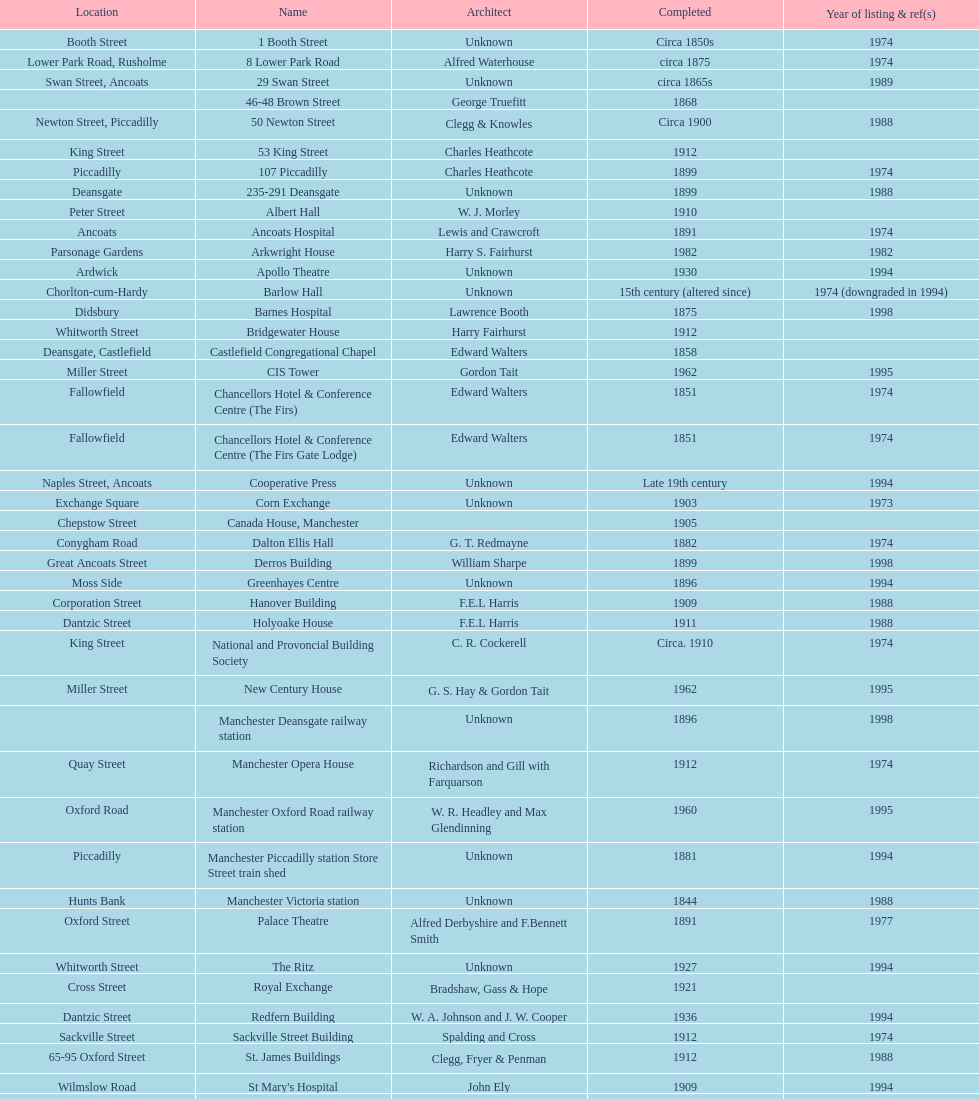How many names are listed with an image? 39. Would you be able to parse every entry in this table? {'header': ['Location', 'Name', 'Architect', 'Completed', 'Year of listing & ref(s)'], 'rows': [['Booth Street', '1 Booth Street', 'Unknown', 'Circa 1850s', '1974'], ['Lower Park Road, Rusholme', '8 Lower Park Road', 'Alfred Waterhouse', 'circa 1875', '1974'], ['Swan Street, Ancoats', '29 Swan Street', 'Unknown', 'circa 1865s', '1989'], ['', '46-48 Brown Street', 'George Truefitt', '1868', ''], ['Newton Street, Piccadilly', '50 Newton Street', 'Clegg & Knowles', 'Circa 1900', '1988'], ['King Street', '53 King Street', 'Charles Heathcote', '1912', ''], ['Piccadilly', '107 Piccadilly', 'Charles Heathcote', '1899', '1974'], ['Deansgate', '235-291 Deansgate', 'Unknown', '1899', '1988'], ['Peter Street', 'Albert Hall', 'W. J. Morley', '1910', ''], ['Ancoats', 'Ancoats Hospital', 'Lewis and Crawcroft', '1891', '1974'], ['Parsonage Gardens', 'Arkwright House', 'Harry S. Fairhurst', '1982', '1982'], ['Ardwick', 'Apollo Theatre', 'Unknown', '1930', '1994'], ['Chorlton-cum-Hardy', 'Barlow Hall', 'Unknown', '15th century (altered since)', '1974 (downgraded in 1994)'], ['Didsbury', 'Barnes Hospital', 'Lawrence Booth', '1875', '1998'], ['Whitworth Street', 'Bridgewater House', 'Harry Fairhurst', '1912', ''], ['Deansgate, Castlefield', 'Castlefield Congregational Chapel', 'Edward Walters', '1858', ''], ['Miller Street', 'CIS Tower', 'Gordon Tait', '1962', '1995'], ['Fallowfield', 'Chancellors Hotel & Conference Centre (The Firs)', 'Edward Walters', '1851', '1974'], ['Fallowfield', 'Chancellors Hotel & Conference Centre (The Firs Gate Lodge)', 'Edward Walters', '1851', '1974'], ['Naples Street, Ancoats', 'Cooperative Press', 'Unknown', 'Late 19th century', '1994'], ['Exchange Square', 'Corn Exchange', 'Unknown', '1903', '1973'], ['Chepstow Street', 'Canada House, Manchester', '', '1905', ''], ['Conygham Road', 'Dalton Ellis Hall', 'G. T. Redmayne', '1882', '1974'], ['Great Ancoats Street', 'Derros Building', 'William Sharpe', '1899', '1998'], ['Moss Side', 'Greenhayes Centre', 'Unknown', '1896', '1994'], ['Corporation Street', 'Hanover Building', 'F.E.L Harris', '1909', '1988'], ['Dantzic Street', 'Holyoake House', 'F.E.L Harris', '1911', '1988'], ['King Street', 'National and Provoncial Building Society', 'C. R. Cockerell', 'Circa. 1910', '1974'], ['Miller Street', 'New Century House', 'G. S. Hay & Gordon Tait', '1962', '1995'], ['', 'Manchester Deansgate railway station', 'Unknown', '1896', '1998'], ['Quay Street', 'Manchester Opera House', 'Richardson and Gill with Farquarson', '1912', '1974'], ['Oxford Road', 'Manchester Oxford Road railway station', 'W. R. Headley and Max Glendinning', '1960', '1995'], ['Piccadilly', 'Manchester Piccadilly station Store Street train shed', 'Unknown', '1881', '1994'], ['Hunts Bank', 'Manchester Victoria station', 'Unknown', '1844', '1988'], ['Oxford Street', 'Palace Theatre', 'Alfred Derbyshire and F.Bennett Smith', '1891', '1977'], ['Whitworth Street', 'The Ritz', 'Unknown', '1927', '1994'], ['Cross Street', 'Royal Exchange', 'Bradshaw, Gass & Hope', '1921', ''], ['Dantzic Street', 'Redfern Building', 'W. A. Johnson and J. W. Cooper', '1936', '1994'], ['Sackville Street', 'Sackville Street Building', 'Spalding and Cross', '1912', '1974'], ['65-95 Oxford Street', 'St. James Buildings', 'Clegg, Fryer & Penman', '1912', '1988'], ['Wilmslow Road', "St Mary's Hospital", 'John Ely', '1909', '1994'], ['Oxford Road', 'Samuel Alexander Building', 'Percy Scott Worthington', '1919', '2010'], ['King Street', 'Ship Canal House', 'Harry S. Fairhurst', '1927', '1982'], ['Swan Street, Ancoats', 'Smithfield Market Hall', 'Unknown', '1857', '1973'], ['Sherborne Street', 'Strangeways Gaol Gatehouse', 'Alfred Waterhouse', '1868', '1974'], ['Sherborne Street', 'Strangeways Prison ventilation and watch tower', 'Alfred Waterhouse', '1868', '1974'], ['Peter Street', 'Theatre Royal', 'Irwin and Chester', '1845', '1974'], ['Fallowfield', 'Toast Rack', 'L. C. Howitt', '1960', '1999'], ['Shambles Square', 'The Old Wellington Inn', 'Unknown', 'Mid-16th century', '1952'], ['Whitworth Park', 'Whitworth Park Mansions', 'Unknown', 'Circa 1840s', '1974']]} 